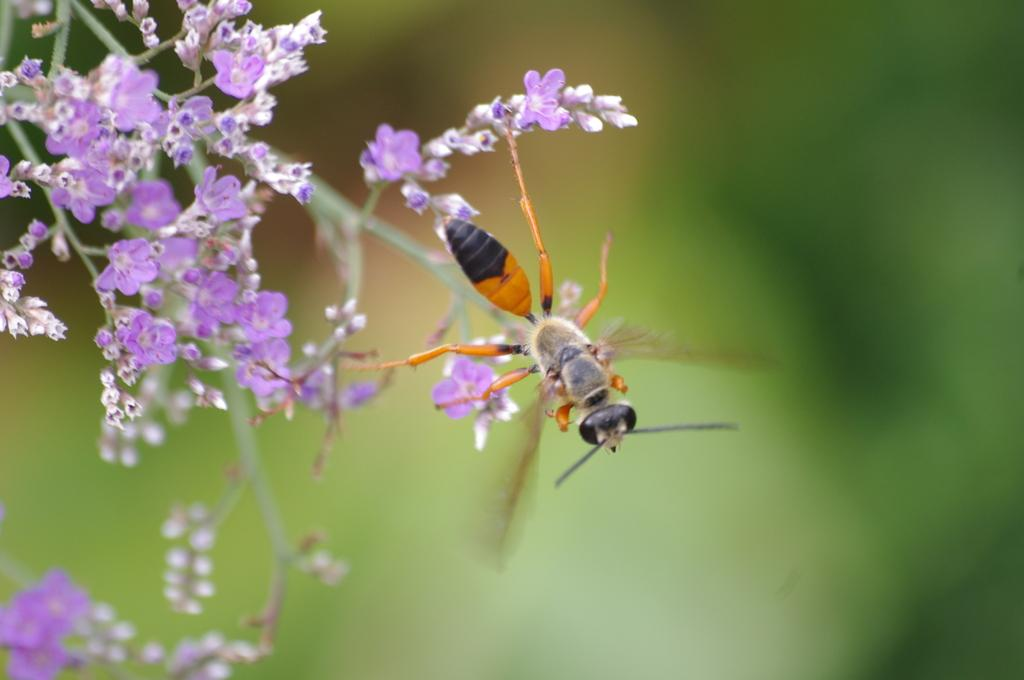What is located on the top left of the image? There is a bunch of flowers on the top left of the image. Can you identify any living organisms in the image? Yes, there is an ant in the image. How would you describe the background of the image? The background of the image is blurred. How many bananas are hanging from the flowers in the image? There are no bananas present in the image; it features a bunch of flowers. What type of crack can be seen in the image? There is no crack present in the image. 